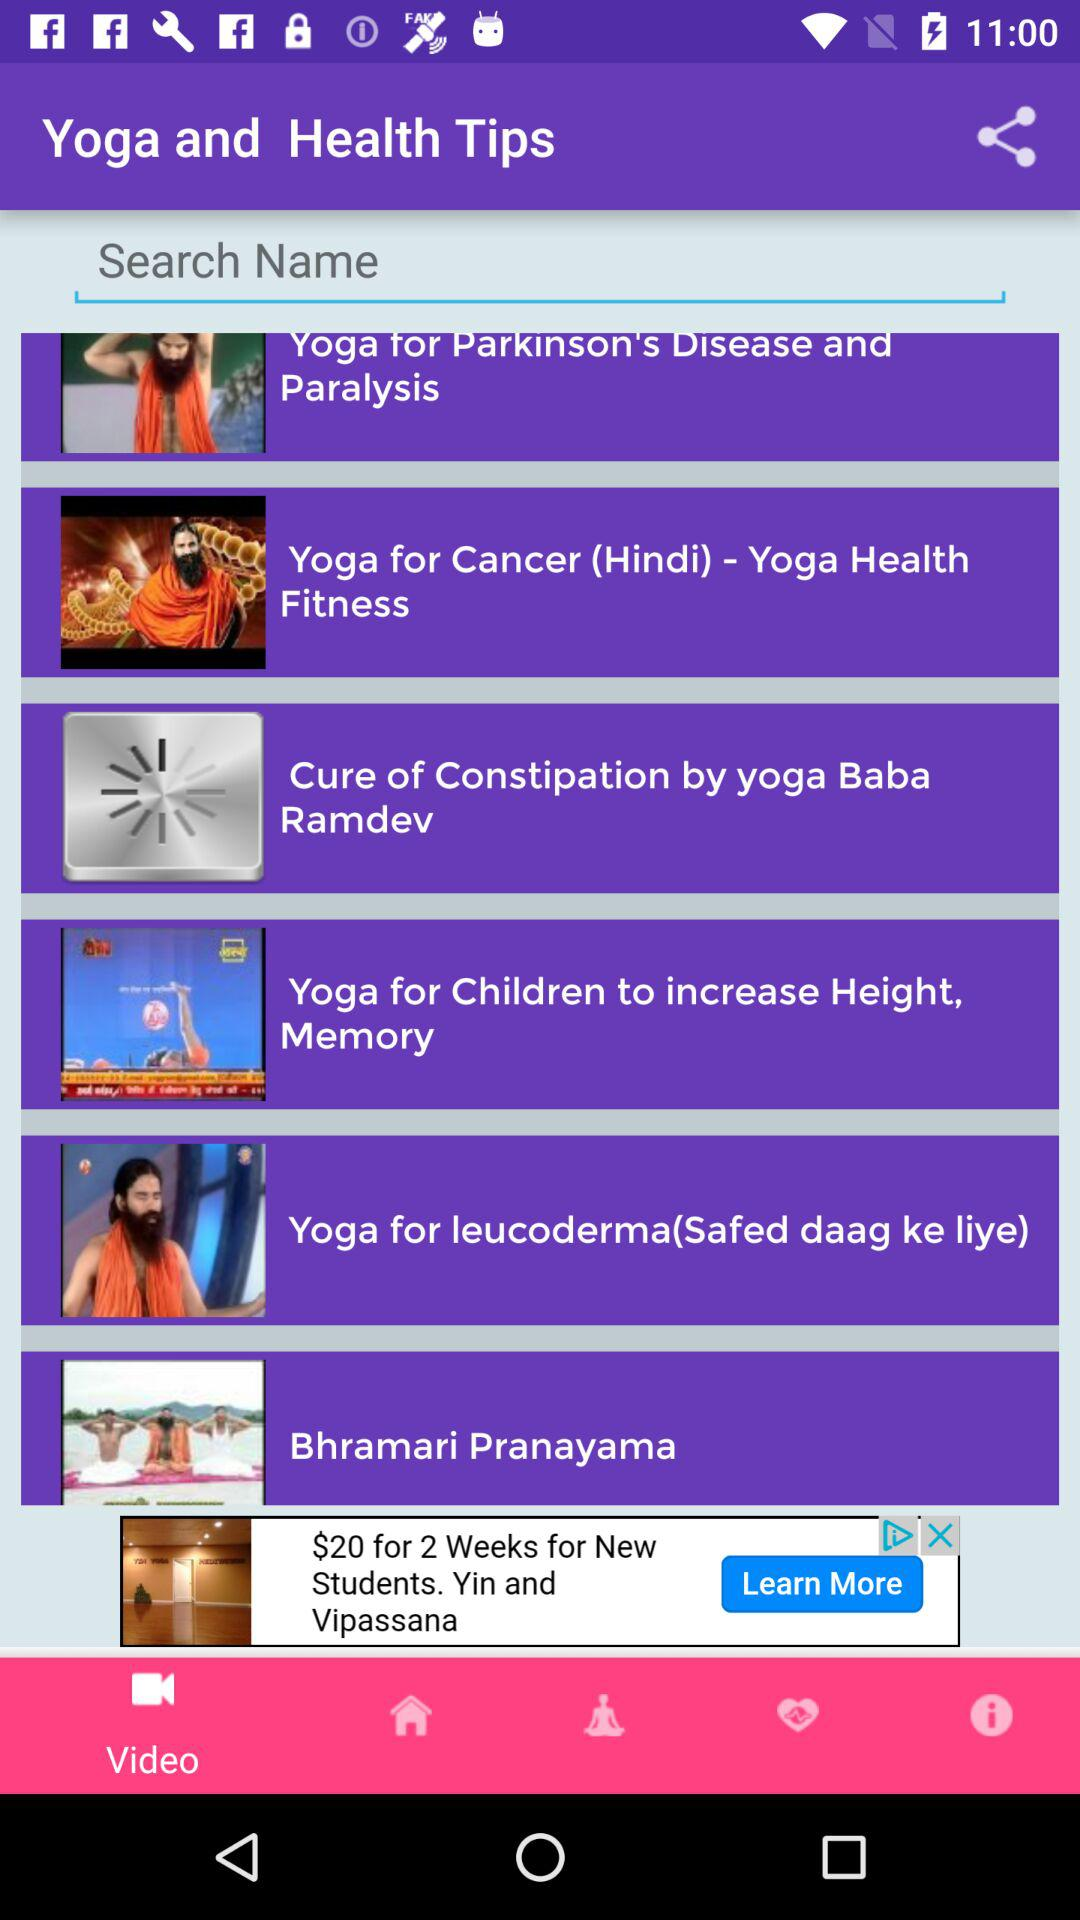Which tab is selected? The selected tab is "Video". 